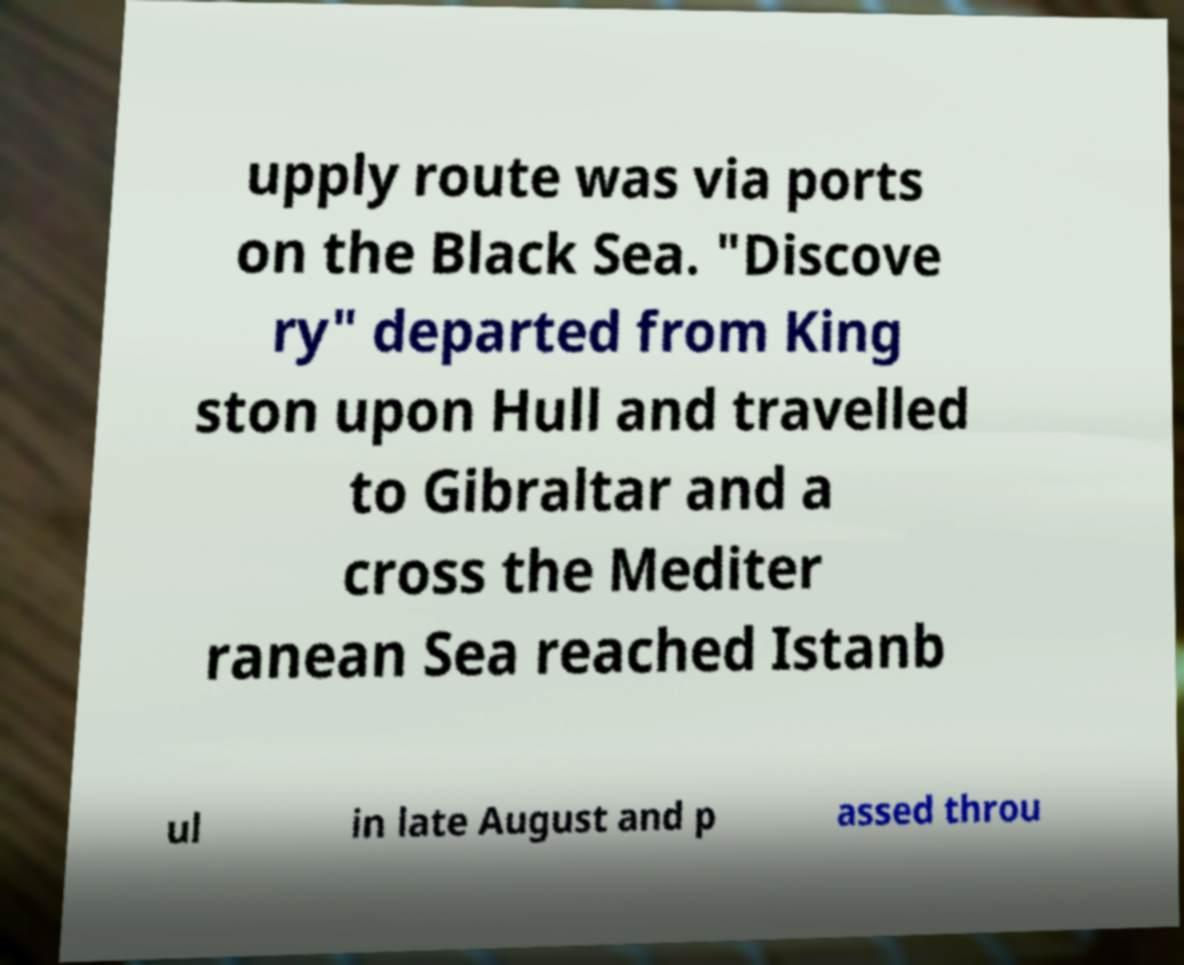What messages or text are displayed in this image? I need them in a readable, typed format. upply route was via ports on the Black Sea. "Discove ry" departed from King ston upon Hull and travelled to Gibraltar and a cross the Mediter ranean Sea reached Istanb ul in late August and p assed throu 